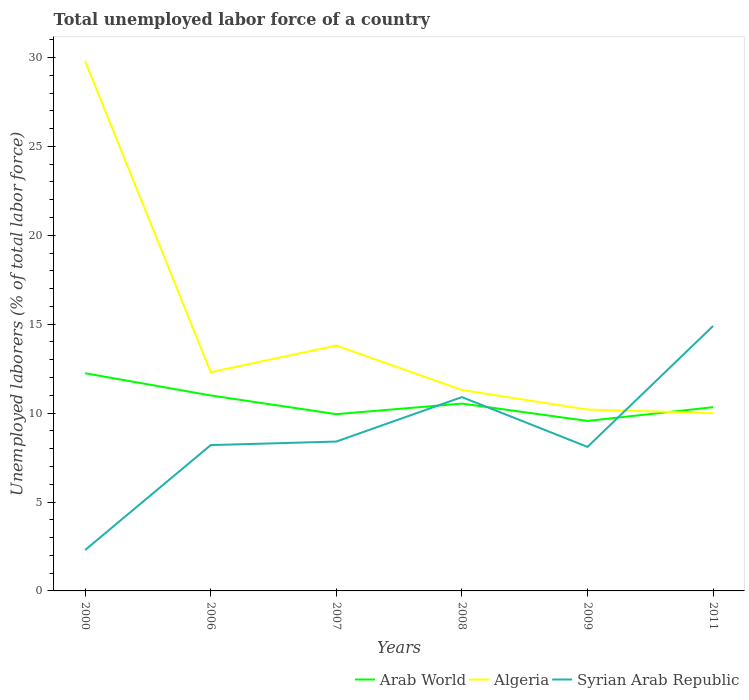How many different coloured lines are there?
Your answer should be compact. 3. Does the line corresponding to Algeria intersect with the line corresponding to Syrian Arab Republic?
Keep it short and to the point. Yes. Across all years, what is the maximum total unemployed labor force in Syrian Arab Republic?
Your answer should be compact. 2.3. In which year was the total unemployed labor force in Syrian Arab Republic maximum?
Offer a very short reply. 2000. What is the total total unemployed labor force in Algeria in the graph?
Your response must be concise. 19.6. What is the difference between the highest and the second highest total unemployed labor force in Syrian Arab Republic?
Give a very brief answer. 12.6. What is the difference between the highest and the lowest total unemployed labor force in Arab World?
Keep it short and to the point. 2. How many lines are there?
Your answer should be compact. 3. How many years are there in the graph?
Your answer should be very brief. 6. What is the difference between two consecutive major ticks on the Y-axis?
Your response must be concise. 5. Where does the legend appear in the graph?
Your answer should be very brief. Bottom right. How are the legend labels stacked?
Your answer should be compact. Horizontal. What is the title of the graph?
Keep it short and to the point. Total unemployed labor force of a country. What is the label or title of the X-axis?
Provide a short and direct response. Years. What is the label or title of the Y-axis?
Offer a terse response. Unemployed laborers (% of total labor force). What is the Unemployed laborers (% of total labor force) of Arab World in 2000?
Provide a succinct answer. 12.24. What is the Unemployed laborers (% of total labor force) in Algeria in 2000?
Make the answer very short. 29.8. What is the Unemployed laborers (% of total labor force) in Syrian Arab Republic in 2000?
Ensure brevity in your answer.  2.3. What is the Unemployed laborers (% of total labor force) of Arab World in 2006?
Provide a succinct answer. 10.99. What is the Unemployed laborers (% of total labor force) of Algeria in 2006?
Provide a short and direct response. 12.3. What is the Unemployed laborers (% of total labor force) in Syrian Arab Republic in 2006?
Offer a terse response. 8.2. What is the Unemployed laborers (% of total labor force) of Arab World in 2007?
Ensure brevity in your answer.  9.94. What is the Unemployed laborers (% of total labor force) of Algeria in 2007?
Give a very brief answer. 13.8. What is the Unemployed laborers (% of total labor force) of Syrian Arab Republic in 2007?
Ensure brevity in your answer.  8.4. What is the Unemployed laborers (% of total labor force) of Arab World in 2008?
Offer a very short reply. 10.54. What is the Unemployed laborers (% of total labor force) of Algeria in 2008?
Give a very brief answer. 11.3. What is the Unemployed laborers (% of total labor force) in Syrian Arab Republic in 2008?
Make the answer very short. 10.9. What is the Unemployed laborers (% of total labor force) of Arab World in 2009?
Keep it short and to the point. 9.56. What is the Unemployed laborers (% of total labor force) in Algeria in 2009?
Your answer should be compact. 10.2. What is the Unemployed laborers (% of total labor force) in Syrian Arab Republic in 2009?
Provide a short and direct response. 8.1. What is the Unemployed laborers (% of total labor force) of Arab World in 2011?
Offer a terse response. 10.33. What is the Unemployed laborers (% of total labor force) in Syrian Arab Republic in 2011?
Your answer should be very brief. 14.9. Across all years, what is the maximum Unemployed laborers (% of total labor force) of Arab World?
Keep it short and to the point. 12.24. Across all years, what is the maximum Unemployed laborers (% of total labor force) in Algeria?
Offer a terse response. 29.8. Across all years, what is the maximum Unemployed laborers (% of total labor force) in Syrian Arab Republic?
Offer a terse response. 14.9. Across all years, what is the minimum Unemployed laborers (% of total labor force) in Arab World?
Ensure brevity in your answer.  9.56. Across all years, what is the minimum Unemployed laborers (% of total labor force) in Algeria?
Make the answer very short. 10. Across all years, what is the minimum Unemployed laborers (% of total labor force) in Syrian Arab Republic?
Keep it short and to the point. 2.3. What is the total Unemployed laborers (% of total labor force) of Arab World in the graph?
Provide a succinct answer. 63.6. What is the total Unemployed laborers (% of total labor force) of Algeria in the graph?
Offer a very short reply. 87.4. What is the total Unemployed laborers (% of total labor force) of Syrian Arab Republic in the graph?
Make the answer very short. 52.8. What is the difference between the Unemployed laborers (% of total labor force) in Arab World in 2000 and that in 2006?
Provide a succinct answer. 1.25. What is the difference between the Unemployed laborers (% of total labor force) of Arab World in 2000 and that in 2007?
Your answer should be very brief. 2.3. What is the difference between the Unemployed laborers (% of total labor force) of Algeria in 2000 and that in 2007?
Your response must be concise. 16. What is the difference between the Unemployed laborers (% of total labor force) of Arab World in 2000 and that in 2008?
Offer a terse response. 1.71. What is the difference between the Unemployed laborers (% of total labor force) of Arab World in 2000 and that in 2009?
Give a very brief answer. 2.68. What is the difference between the Unemployed laborers (% of total labor force) in Algeria in 2000 and that in 2009?
Ensure brevity in your answer.  19.6. What is the difference between the Unemployed laborers (% of total labor force) of Syrian Arab Republic in 2000 and that in 2009?
Provide a succinct answer. -5.8. What is the difference between the Unemployed laborers (% of total labor force) in Arab World in 2000 and that in 2011?
Offer a terse response. 1.91. What is the difference between the Unemployed laborers (% of total labor force) of Algeria in 2000 and that in 2011?
Ensure brevity in your answer.  19.8. What is the difference between the Unemployed laborers (% of total labor force) in Syrian Arab Republic in 2000 and that in 2011?
Offer a terse response. -12.6. What is the difference between the Unemployed laborers (% of total labor force) in Arab World in 2006 and that in 2007?
Your answer should be very brief. 1.05. What is the difference between the Unemployed laborers (% of total labor force) in Algeria in 2006 and that in 2007?
Provide a short and direct response. -1.5. What is the difference between the Unemployed laborers (% of total labor force) in Arab World in 2006 and that in 2008?
Offer a terse response. 0.46. What is the difference between the Unemployed laborers (% of total labor force) of Arab World in 2006 and that in 2009?
Ensure brevity in your answer.  1.43. What is the difference between the Unemployed laborers (% of total labor force) in Algeria in 2006 and that in 2009?
Give a very brief answer. 2.1. What is the difference between the Unemployed laborers (% of total labor force) of Syrian Arab Republic in 2006 and that in 2009?
Provide a short and direct response. 0.1. What is the difference between the Unemployed laborers (% of total labor force) of Arab World in 2006 and that in 2011?
Offer a terse response. 0.66. What is the difference between the Unemployed laborers (% of total labor force) of Arab World in 2007 and that in 2008?
Give a very brief answer. -0.59. What is the difference between the Unemployed laborers (% of total labor force) in Algeria in 2007 and that in 2008?
Offer a terse response. 2.5. What is the difference between the Unemployed laborers (% of total labor force) in Arab World in 2007 and that in 2009?
Give a very brief answer. 0.38. What is the difference between the Unemployed laborers (% of total labor force) in Algeria in 2007 and that in 2009?
Make the answer very short. 3.6. What is the difference between the Unemployed laborers (% of total labor force) in Syrian Arab Republic in 2007 and that in 2009?
Give a very brief answer. 0.3. What is the difference between the Unemployed laborers (% of total labor force) of Arab World in 2007 and that in 2011?
Your response must be concise. -0.39. What is the difference between the Unemployed laborers (% of total labor force) of Algeria in 2007 and that in 2011?
Your response must be concise. 3.8. What is the difference between the Unemployed laborers (% of total labor force) of Arab World in 2008 and that in 2009?
Ensure brevity in your answer.  0.97. What is the difference between the Unemployed laborers (% of total labor force) in Arab World in 2008 and that in 2011?
Offer a terse response. 0.2. What is the difference between the Unemployed laborers (% of total labor force) of Algeria in 2008 and that in 2011?
Your response must be concise. 1.3. What is the difference between the Unemployed laborers (% of total labor force) of Arab World in 2009 and that in 2011?
Give a very brief answer. -0.77. What is the difference between the Unemployed laborers (% of total labor force) of Algeria in 2009 and that in 2011?
Offer a very short reply. 0.2. What is the difference between the Unemployed laborers (% of total labor force) of Syrian Arab Republic in 2009 and that in 2011?
Provide a short and direct response. -6.8. What is the difference between the Unemployed laborers (% of total labor force) in Arab World in 2000 and the Unemployed laborers (% of total labor force) in Algeria in 2006?
Make the answer very short. -0.06. What is the difference between the Unemployed laborers (% of total labor force) of Arab World in 2000 and the Unemployed laborers (% of total labor force) of Syrian Arab Republic in 2006?
Ensure brevity in your answer.  4.04. What is the difference between the Unemployed laborers (% of total labor force) of Algeria in 2000 and the Unemployed laborers (% of total labor force) of Syrian Arab Republic in 2006?
Offer a terse response. 21.6. What is the difference between the Unemployed laborers (% of total labor force) of Arab World in 2000 and the Unemployed laborers (% of total labor force) of Algeria in 2007?
Keep it short and to the point. -1.56. What is the difference between the Unemployed laborers (% of total labor force) of Arab World in 2000 and the Unemployed laborers (% of total labor force) of Syrian Arab Republic in 2007?
Provide a short and direct response. 3.84. What is the difference between the Unemployed laborers (% of total labor force) in Algeria in 2000 and the Unemployed laborers (% of total labor force) in Syrian Arab Republic in 2007?
Your answer should be compact. 21.4. What is the difference between the Unemployed laborers (% of total labor force) of Arab World in 2000 and the Unemployed laborers (% of total labor force) of Algeria in 2008?
Keep it short and to the point. 0.94. What is the difference between the Unemployed laborers (% of total labor force) in Arab World in 2000 and the Unemployed laborers (% of total labor force) in Syrian Arab Republic in 2008?
Make the answer very short. 1.34. What is the difference between the Unemployed laborers (% of total labor force) in Arab World in 2000 and the Unemployed laborers (% of total labor force) in Algeria in 2009?
Provide a short and direct response. 2.04. What is the difference between the Unemployed laborers (% of total labor force) in Arab World in 2000 and the Unemployed laborers (% of total labor force) in Syrian Arab Republic in 2009?
Make the answer very short. 4.14. What is the difference between the Unemployed laborers (% of total labor force) of Algeria in 2000 and the Unemployed laborers (% of total labor force) of Syrian Arab Republic in 2009?
Provide a short and direct response. 21.7. What is the difference between the Unemployed laborers (% of total labor force) of Arab World in 2000 and the Unemployed laborers (% of total labor force) of Algeria in 2011?
Make the answer very short. 2.24. What is the difference between the Unemployed laborers (% of total labor force) in Arab World in 2000 and the Unemployed laborers (% of total labor force) in Syrian Arab Republic in 2011?
Give a very brief answer. -2.66. What is the difference between the Unemployed laborers (% of total labor force) in Arab World in 2006 and the Unemployed laborers (% of total labor force) in Algeria in 2007?
Ensure brevity in your answer.  -2.81. What is the difference between the Unemployed laborers (% of total labor force) of Arab World in 2006 and the Unemployed laborers (% of total labor force) of Syrian Arab Republic in 2007?
Your answer should be very brief. 2.59. What is the difference between the Unemployed laborers (% of total labor force) in Arab World in 2006 and the Unemployed laborers (% of total labor force) in Algeria in 2008?
Provide a short and direct response. -0.31. What is the difference between the Unemployed laborers (% of total labor force) in Arab World in 2006 and the Unemployed laborers (% of total labor force) in Syrian Arab Republic in 2008?
Your response must be concise. 0.09. What is the difference between the Unemployed laborers (% of total labor force) of Arab World in 2006 and the Unemployed laborers (% of total labor force) of Algeria in 2009?
Offer a terse response. 0.79. What is the difference between the Unemployed laborers (% of total labor force) in Arab World in 2006 and the Unemployed laborers (% of total labor force) in Syrian Arab Republic in 2009?
Ensure brevity in your answer.  2.89. What is the difference between the Unemployed laborers (% of total labor force) of Arab World in 2006 and the Unemployed laborers (% of total labor force) of Syrian Arab Republic in 2011?
Keep it short and to the point. -3.91. What is the difference between the Unemployed laborers (% of total labor force) of Arab World in 2007 and the Unemployed laborers (% of total labor force) of Algeria in 2008?
Provide a succinct answer. -1.36. What is the difference between the Unemployed laborers (% of total labor force) of Arab World in 2007 and the Unemployed laborers (% of total labor force) of Syrian Arab Republic in 2008?
Provide a succinct answer. -0.96. What is the difference between the Unemployed laborers (% of total labor force) of Algeria in 2007 and the Unemployed laborers (% of total labor force) of Syrian Arab Republic in 2008?
Make the answer very short. 2.9. What is the difference between the Unemployed laborers (% of total labor force) of Arab World in 2007 and the Unemployed laborers (% of total labor force) of Algeria in 2009?
Your answer should be very brief. -0.26. What is the difference between the Unemployed laborers (% of total labor force) in Arab World in 2007 and the Unemployed laborers (% of total labor force) in Syrian Arab Republic in 2009?
Offer a terse response. 1.84. What is the difference between the Unemployed laborers (% of total labor force) of Algeria in 2007 and the Unemployed laborers (% of total labor force) of Syrian Arab Republic in 2009?
Your answer should be compact. 5.7. What is the difference between the Unemployed laborers (% of total labor force) in Arab World in 2007 and the Unemployed laborers (% of total labor force) in Algeria in 2011?
Keep it short and to the point. -0.06. What is the difference between the Unemployed laborers (% of total labor force) in Arab World in 2007 and the Unemployed laborers (% of total labor force) in Syrian Arab Republic in 2011?
Your response must be concise. -4.96. What is the difference between the Unemployed laborers (% of total labor force) of Arab World in 2008 and the Unemployed laborers (% of total labor force) of Algeria in 2009?
Your answer should be very brief. 0.34. What is the difference between the Unemployed laborers (% of total labor force) in Arab World in 2008 and the Unemployed laborers (% of total labor force) in Syrian Arab Republic in 2009?
Give a very brief answer. 2.44. What is the difference between the Unemployed laborers (% of total labor force) in Arab World in 2008 and the Unemployed laborers (% of total labor force) in Algeria in 2011?
Your answer should be compact. 0.54. What is the difference between the Unemployed laborers (% of total labor force) of Arab World in 2008 and the Unemployed laborers (% of total labor force) of Syrian Arab Republic in 2011?
Provide a succinct answer. -4.36. What is the difference between the Unemployed laborers (% of total labor force) of Algeria in 2008 and the Unemployed laborers (% of total labor force) of Syrian Arab Republic in 2011?
Your answer should be compact. -3.6. What is the difference between the Unemployed laborers (% of total labor force) in Arab World in 2009 and the Unemployed laborers (% of total labor force) in Algeria in 2011?
Give a very brief answer. -0.44. What is the difference between the Unemployed laborers (% of total labor force) in Arab World in 2009 and the Unemployed laborers (% of total labor force) in Syrian Arab Republic in 2011?
Make the answer very short. -5.34. What is the average Unemployed laborers (% of total labor force) in Arab World per year?
Offer a very short reply. 10.6. What is the average Unemployed laborers (% of total labor force) in Algeria per year?
Provide a short and direct response. 14.57. What is the average Unemployed laborers (% of total labor force) of Syrian Arab Republic per year?
Keep it short and to the point. 8.8. In the year 2000, what is the difference between the Unemployed laborers (% of total labor force) in Arab World and Unemployed laborers (% of total labor force) in Algeria?
Provide a succinct answer. -17.56. In the year 2000, what is the difference between the Unemployed laborers (% of total labor force) in Arab World and Unemployed laborers (% of total labor force) in Syrian Arab Republic?
Your answer should be compact. 9.94. In the year 2006, what is the difference between the Unemployed laborers (% of total labor force) in Arab World and Unemployed laborers (% of total labor force) in Algeria?
Ensure brevity in your answer.  -1.31. In the year 2006, what is the difference between the Unemployed laborers (% of total labor force) of Arab World and Unemployed laborers (% of total labor force) of Syrian Arab Republic?
Offer a terse response. 2.79. In the year 2006, what is the difference between the Unemployed laborers (% of total labor force) in Algeria and Unemployed laborers (% of total labor force) in Syrian Arab Republic?
Your answer should be compact. 4.1. In the year 2007, what is the difference between the Unemployed laborers (% of total labor force) of Arab World and Unemployed laborers (% of total labor force) of Algeria?
Make the answer very short. -3.86. In the year 2007, what is the difference between the Unemployed laborers (% of total labor force) in Arab World and Unemployed laborers (% of total labor force) in Syrian Arab Republic?
Offer a very short reply. 1.54. In the year 2008, what is the difference between the Unemployed laborers (% of total labor force) in Arab World and Unemployed laborers (% of total labor force) in Algeria?
Keep it short and to the point. -0.76. In the year 2008, what is the difference between the Unemployed laborers (% of total labor force) of Arab World and Unemployed laborers (% of total labor force) of Syrian Arab Republic?
Provide a short and direct response. -0.36. In the year 2009, what is the difference between the Unemployed laborers (% of total labor force) in Arab World and Unemployed laborers (% of total labor force) in Algeria?
Your answer should be compact. -0.64. In the year 2009, what is the difference between the Unemployed laborers (% of total labor force) in Arab World and Unemployed laborers (% of total labor force) in Syrian Arab Republic?
Make the answer very short. 1.46. In the year 2009, what is the difference between the Unemployed laborers (% of total labor force) in Algeria and Unemployed laborers (% of total labor force) in Syrian Arab Republic?
Provide a short and direct response. 2.1. In the year 2011, what is the difference between the Unemployed laborers (% of total labor force) in Arab World and Unemployed laborers (% of total labor force) in Algeria?
Ensure brevity in your answer.  0.33. In the year 2011, what is the difference between the Unemployed laborers (% of total labor force) in Arab World and Unemployed laborers (% of total labor force) in Syrian Arab Republic?
Your answer should be very brief. -4.57. What is the ratio of the Unemployed laborers (% of total labor force) of Arab World in 2000 to that in 2006?
Make the answer very short. 1.11. What is the ratio of the Unemployed laborers (% of total labor force) in Algeria in 2000 to that in 2006?
Ensure brevity in your answer.  2.42. What is the ratio of the Unemployed laborers (% of total labor force) of Syrian Arab Republic in 2000 to that in 2006?
Ensure brevity in your answer.  0.28. What is the ratio of the Unemployed laborers (% of total labor force) of Arab World in 2000 to that in 2007?
Keep it short and to the point. 1.23. What is the ratio of the Unemployed laborers (% of total labor force) in Algeria in 2000 to that in 2007?
Give a very brief answer. 2.16. What is the ratio of the Unemployed laborers (% of total labor force) in Syrian Arab Republic in 2000 to that in 2007?
Offer a very short reply. 0.27. What is the ratio of the Unemployed laborers (% of total labor force) of Arab World in 2000 to that in 2008?
Offer a very short reply. 1.16. What is the ratio of the Unemployed laborers (% of total labor force) in Algeria in 2000 to that in 2008?
Your answer should be compact. 2.64. What is the ratio of the Unemployed laborers (% of total labor force) of Syrian Arab Republic in 2000 to that in 2008?
Give a very brief answer. 0.21. What is the ratio of the Unemployed laborers (% of total labor force) in Arab World in 2000 to that in 2009?
Offer a terse response. 1.28. What is the ratio of the Unemployed laborers (% of total labor force) of Algeria in 2000 to that in 2009?
Your answer should be very brief. 2.92. What is the ratio of the Unemployed laborers (% of total labor force) of Syrian Arab Republic in 2000 to that in 2009?
Give a very brief answer. 0.28. What is the ratio of the Unemployed laborers (% of total labor force) in Arab World in 2000 to that in 2011?
Offer a terse response. 1.18. What is the ratio of the Unemployed laborers (% of total labor force) of Algeria in 2000 to that in 2011?
Provide a short and direct response. 2.98. What is the ratio of the Unemployed laborers (% of total labor force) of Syrian Arab Republic in 2000 to that in 2011?
Provide a short and direct response. 0.15. What is the ratio of the Unemployed laborers (% of total labor force) of Arab World in 2006 to that in 2007?
Offer a terse response. 1.11. What is the ratio of the Unemployed laborers (% of total labor force) of Algeria in 2006 to that in 2007?
Ensure brevity in your answer.  0.89. What is the ratio of the Unemployed laborers (% of total labor force) of Syrian Arab Republic in 2006 to that in 2007?
Ensure brevity in your answer.  0.98. What is the ratio of the Unemployed laborers (% of total labor force) in Arab World in 2006 to that in 2008?
Provide a short and direct response. 1.04. What is the ratio of the Unemployed laborers (% of total labor force) in Algeria in 2006 to that in 2008?
Your answer should be very brief. 1.09. What is the ratio of the Unemployed laborers (% of total labor force) of Syrian Arab Republic in 2006 to that in 2008?
Provide a short and direct response. 0.75. What is the ratio of the Unemployed laborers (% of total labor force) in Arab World in 2006 to that in 2009?
Your answer should be very brief. 1.15. What is the ratio of the Unemployed laborers (% of total labor force) in Algeria in 2006 to that in 2009?
Ensure brevity in your answer.  1.21. What is the ratio of the Unemployed laborers (% of total labor force) in Syrian Arab Republic in 2006 to that in 2009?
Ensure brevity in your answer.  1.01. What is the ratio of the Unemployed laborers (% of total labor force) of Arab World in 2006 to that in 2011?
Make the answer very short. 1.06. What is the ratio of the Unemployed laborers (% of total labor force) of Algeria in 2006 to that in 2011?
Your answer should be very brief. 1.23. What is the ratio of the Unemployed laborers (% of total labor force) in Syrian Arab Republic in 2006 to that in 2011?
Give a very brief answer. 0.55. What is the ratio of the Unemployed laborers (% of total labor force) in Arab World in 2007 to that in 2008?
Provide a succinct answer. 0.94. What is the ratio of the Unemployed laborers (% of total labor force) in Algeria in 2007 to that in 2008?
Your answer should be compact. 1.22. What is the ratio of the Unemployed laborers (% of total labor force) of Syrian Arab Republic in 2007 to that in 2008?
Keep it short and to the point. 0.77. What is the ratio of the Unemployed laborers (% of total labor force) in Arab World in 2007 to that in 2009?
Your response must be concise. 1.04. What is the ratio of the Unemployed laborers (% of total labor force) of Algeria in 2007 to that in 2009?
Provide a succinct answer. 1.35. What is the ratio of the Unemployed laborers (% of total labor force) of Algeria in 2007 to that in 2011?
Give a very brief answer. 1.38. What is the ratio of the Unemployed laborers (% of total labor force) in Syrian Arab Republic in 2007 to that in 2011?
Offer a very short reply. 0.56. What is the ratio of the Unemployed laborers (% of total labor force) of Arab World in 2008 to that in 2009?
Your answer should be compact. 1.1. What is the ratio of the Unemployed laborers (% of total labor force) in Algeria in 2008 to that in 2009?
Make the answer very short. 1.11. What is the ratio of the Unemployed laborers (% of total labor force) of Syrian Arab Republic in 2008 to that in 2009?
Your answer should be compact. 1.35. What is the ratio of the Unemployed laborers (% of total labor force) of Arab World in 2008 to that in 2011?
Keep it short and to the point. 1.02. What is the ratio of the Unemployed laborers (% of total labor force) in Algeria in 2008 to that in 2011?
Your answer should be very brief. 1.13. What is the ratio of the Unemployed laborers (% of total labor force) of Syrian Arab Republic in 2008 to that in 2011?
Your response must be concise. 0.73. What is the ratio of the Unemployed laborers (% of total labor force) in Arab World in 2009 to that in 2011?
Give a very brief answer. 0.93. What is the ratio of the Unemployed laborers (% of total labor force) of Algeria in 2009 to that in 2011?
Your answer should be very brief. 1.02. What is the ratio of the Unemployed laborers (% of total labor force) of Syrian Arab Republic in 2009 to that in 2011?
Your answer should be compact. 0.54. What is the difference between the highest and the second highest Unemployed laborers (% of total labor force) in Arab World?
Provide a short and direct response. 1.25. What is the difference between the highest and the second highest Unemployed laborers (% of total labor force) in Algeria?
Your response must be concise. 16. What is the difference between the highest and the lowest Unemployed laborers (% of total labor force) in Arab World?
Make the answer very short. 2.68. What is the difference between the highest and the lowest Unemployed laborers (% of total labor force) of Algeria?
Keep it short and to the point. 19.8. What is the difference between the highest and the lowest Unemployed laborers (% of total labor force) in Syrian Arab Republic?
Your response must be concise. 12.6. 